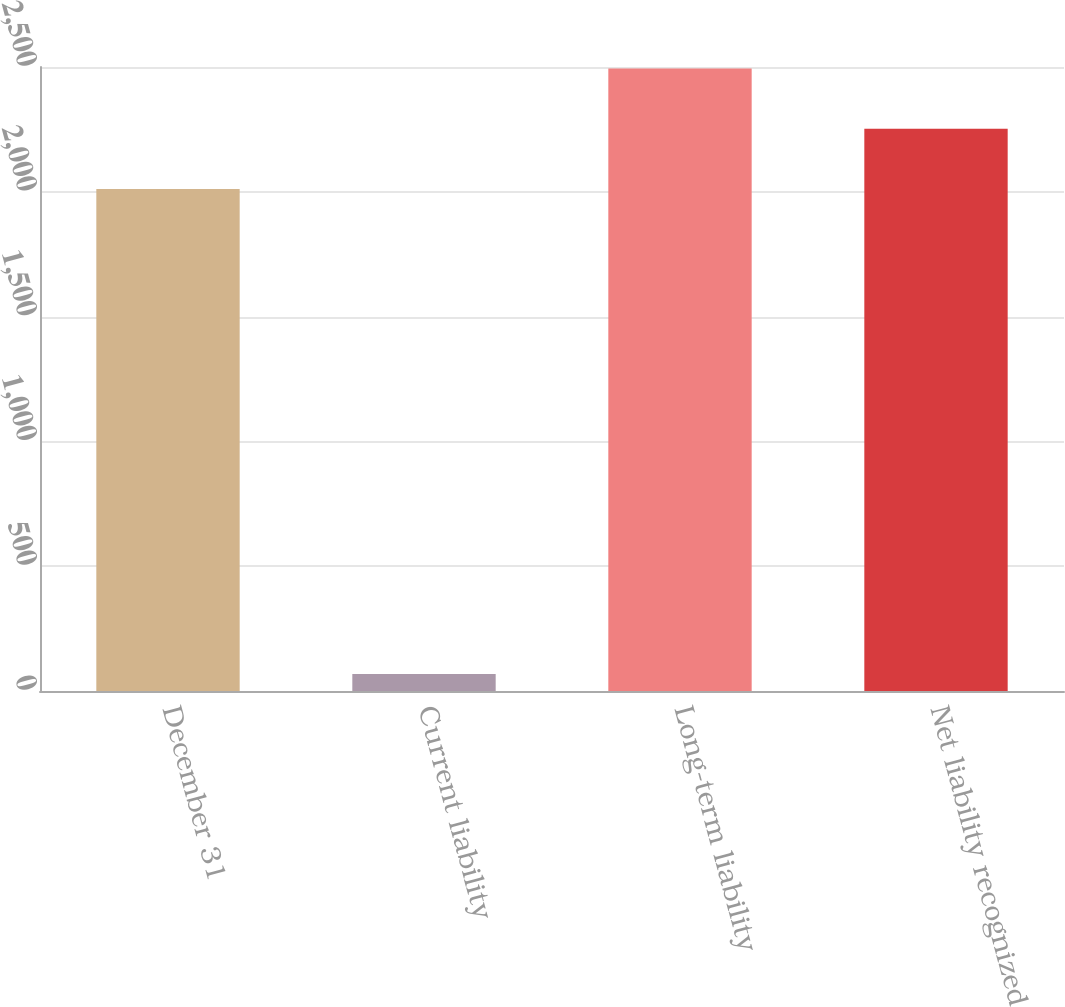Convert chart. <chart><loc_0><loc_0><loc_500><loc_500><bar_chart><fcel>December 31<fcel>Current liability<fcel>Long-term liability<fcel>Net liability recognized<nl><fcel>2011<fcel>68<fcel>2494.2<fcel>2252.6<nl></chart> 